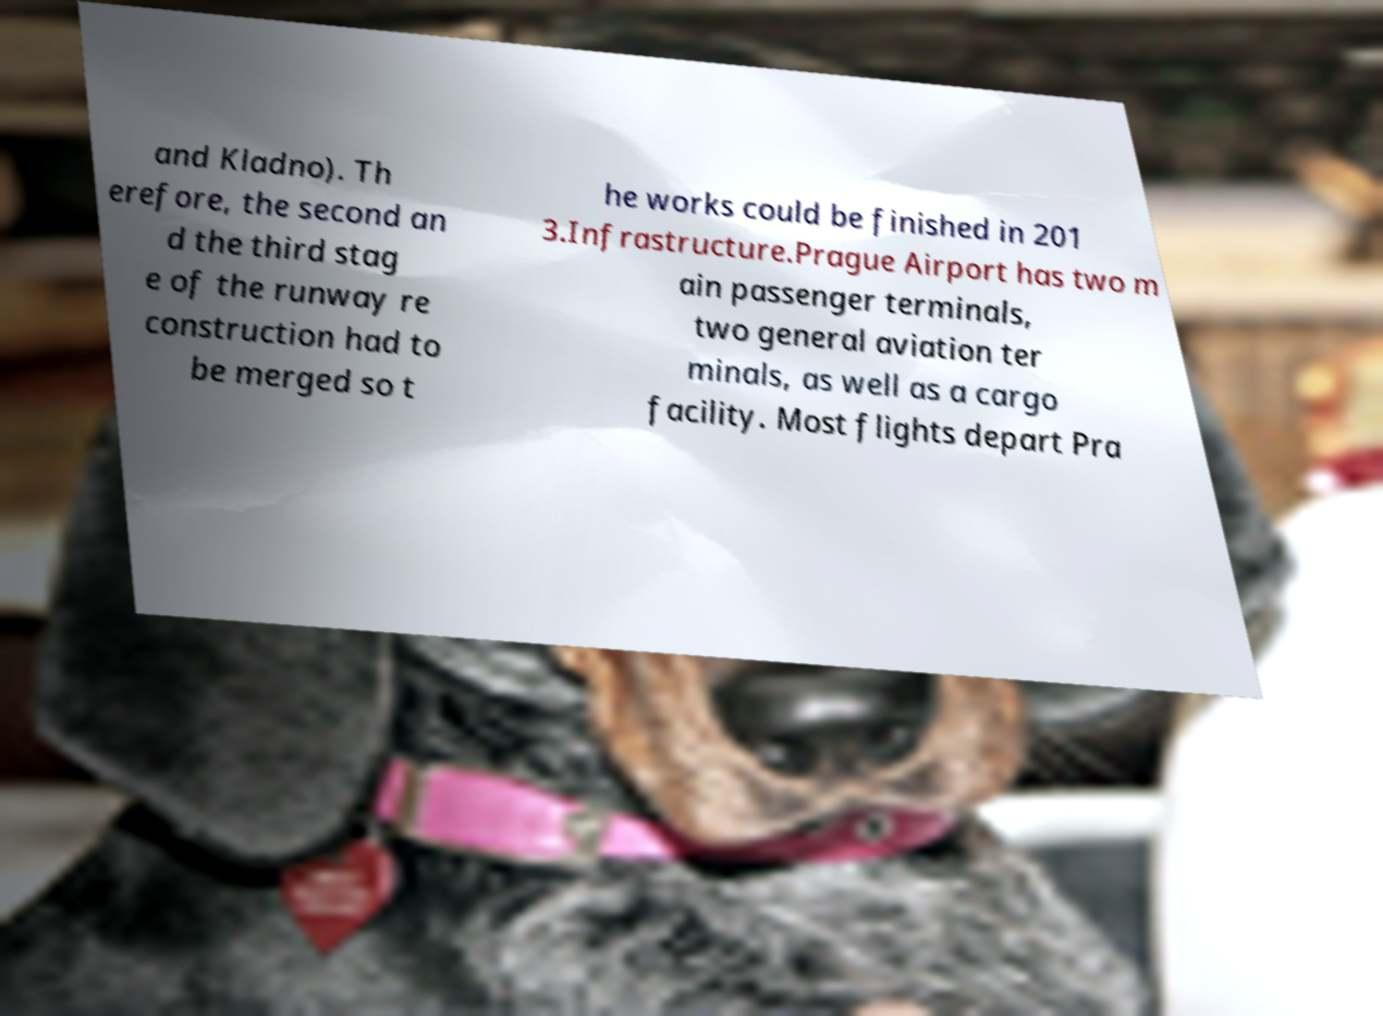Can you accurately transcribe the text from the provided image for me? and Kladno). Th erefore, the second an d the third stag e of the runway re construction had to be merged so t he works could be finished in 201 3.Infrastructure.Prague Airport has two m ain passenger terminals, two general aviation ter minals, as well as a cargo facility. Most flights depart Pra 